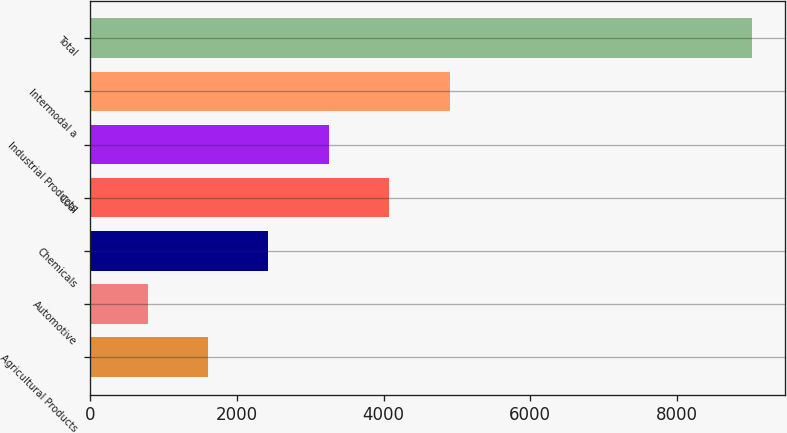Convert chart to OTSL. <chart><loc_0><loc_0><loc_500><loc_500><bar_chart><fcel>Agricultural Products<fcel>Automotive<fcel>Chemicals<fcel>Coal<fcel>Industrial Products<fcel>Intermodal a<fcel>Total<nl><fcel>1605.1<fcel>781<fcel>2429.2<fcel>4077.4<fcel>3253.3<fcel>4901.5<fcel>9022<nl></chart> 